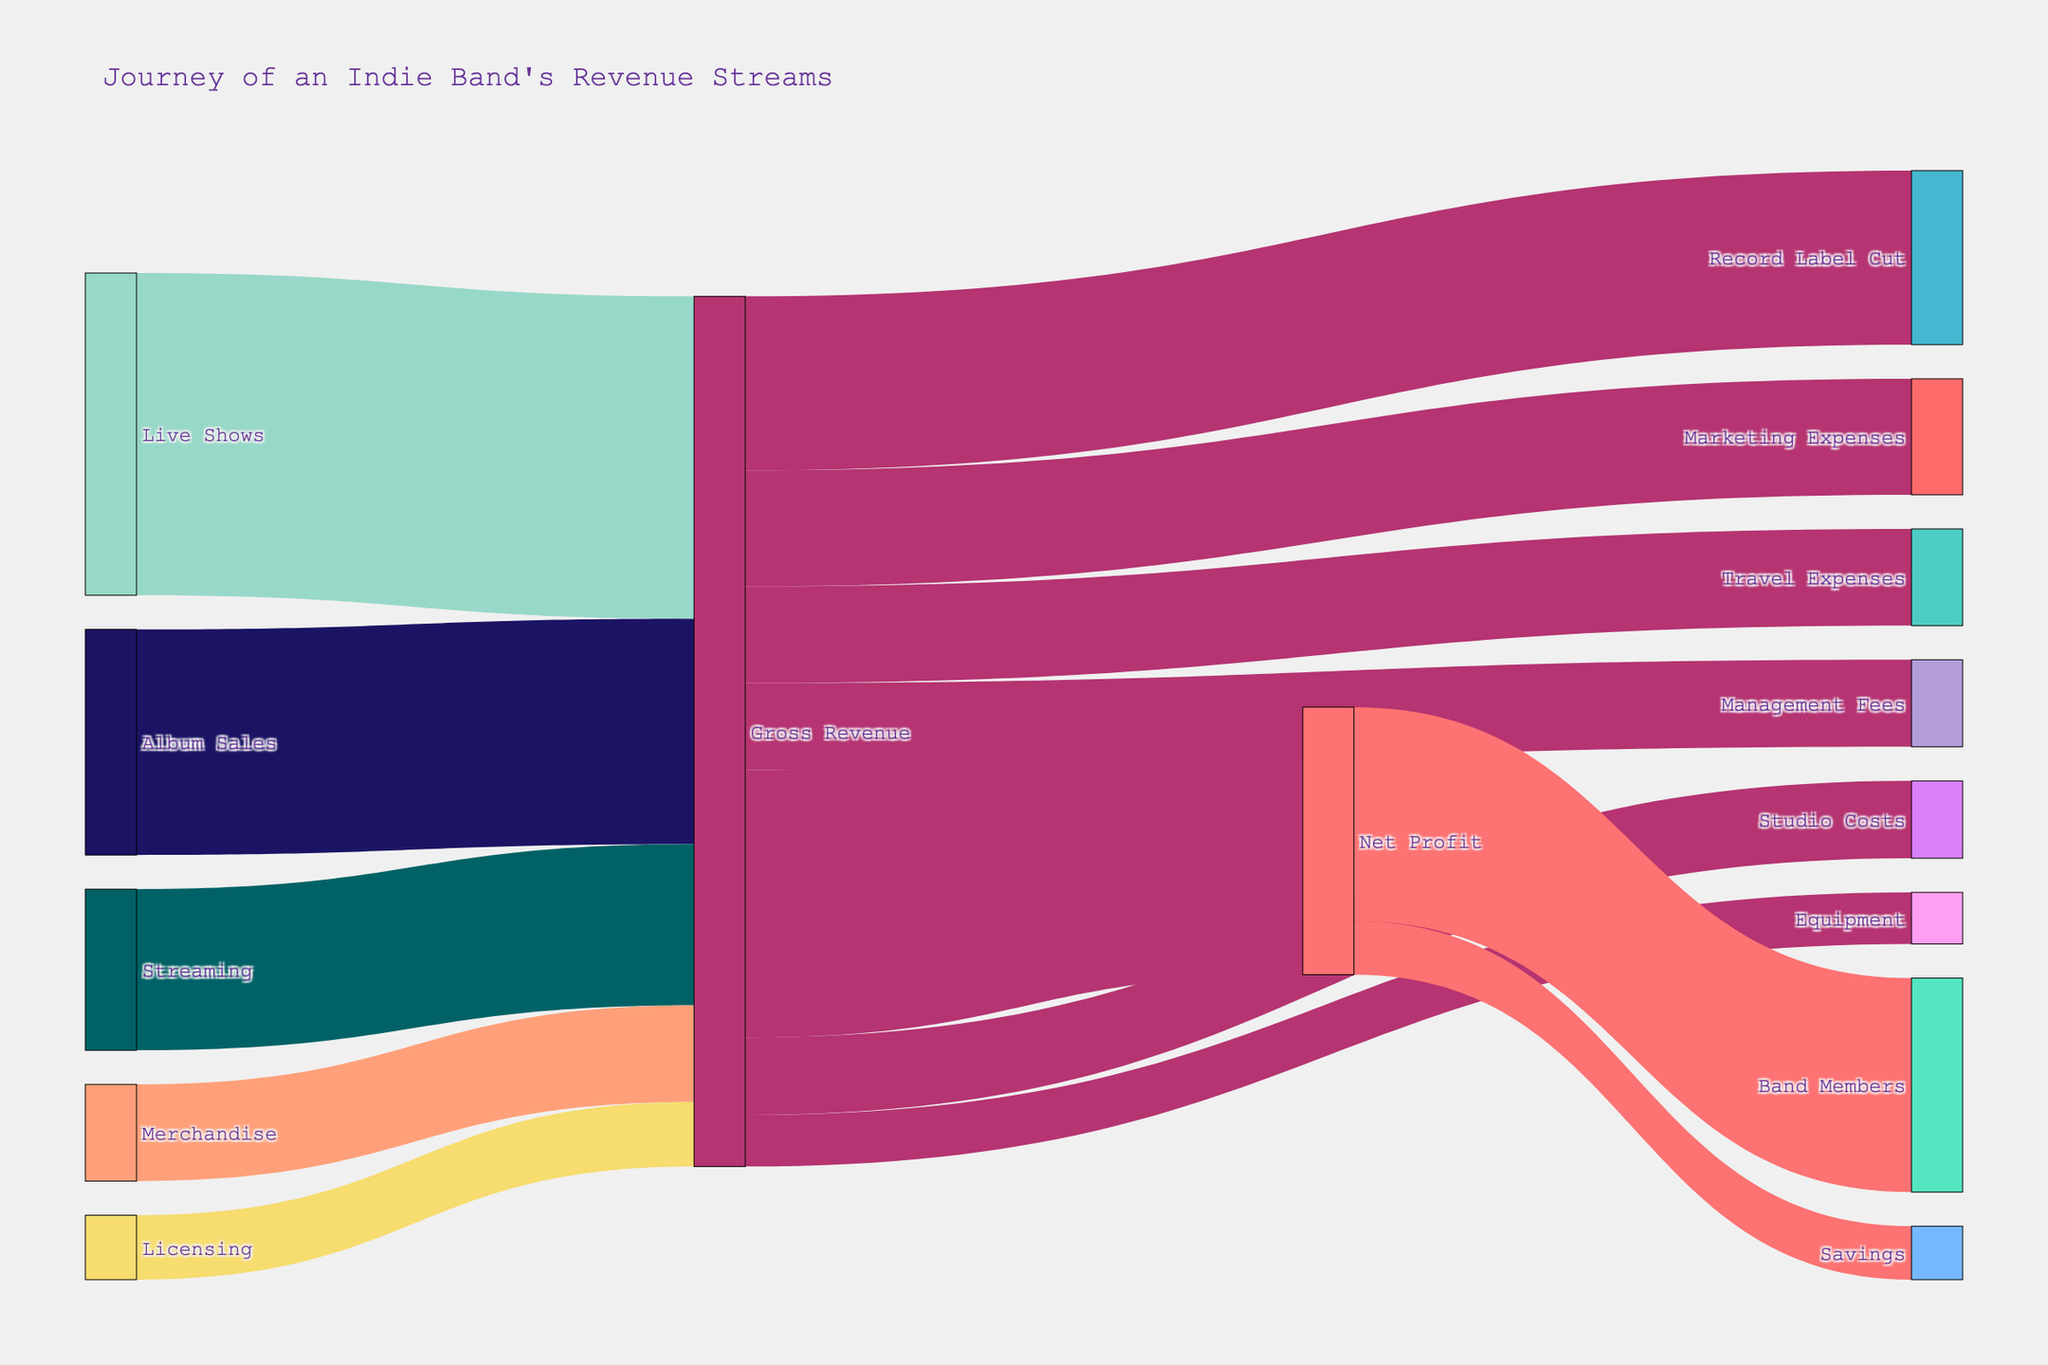what is the total value of gross revenue? To find the total value of gross revenue, sum up all the incoming values directed towards 'Gross Revenue'. This includes Album Sales (35000), Streaming (25000), Merchandise (15000), Live Shows (50000), and Licensing (10000). Summing these values gives us 35000 + 25000 + 15000 + 50000 + 10000 = 135000.
Answer: 135000 What is the largest single expense from the gross revenue? The expenses from Gross Revenue include Record Label Cut (27000), Management Fees (13500), Marketing Expenses (18000), Studio Costs (12000), Equipment (8000), and Travel Expenses (15000). The largest single expense here is the Record Label Cut at 27000.
Answer: 27000 What percentage of gross revenue is net profit? To determine the percentage, the formula is (Net Profit / Gross Revenue) * 100. The Net Profit is 41500, and Gross Revenue is 135000. Hence, (41500 / 135000) * 100 = 30.74%.
Answer: 30.74% How much revenue was directed towards Band Members from net profit? From the chart, we see that from 'Net Profit' (41500), 'Band Members' receive 33200.
Answer: 33200 What is the total value deducted from gross revenue? To find the total value deducted, sum up all the outgoing values from 'Gross Revenue': Record Label Cut (27000), Management Fees (13500), Marketing Expenses (18000), Studio Costs (12000), Equipment (8000), Travel Expenses (15000). Adding these values: 27000 + 13500 + 18000 + 12000 + 8000 + 15000 = 93500.
Answer: 93500 Which revenue source contributes the least to gross revenue? By comparing the values directed towards Gross Revenue, Licensing contributes the least with 10000.
Answer: Licensing What is the difference in value between Album Sales and Streaming? Album Sales contribute 35000, whereas Streaming contributes 25000. The difference is 35000 - 25000 = 10000.
Answer: 10000 How much is saved from the net profit? From the chart, we see that from 'Net Profit' (41500), 'Savings' receives 8300.
Answer: 8300 Which expense is contributed equally to Management Fees and has the same value? Both 'Management Fees' and 'Travel Expenses' from Gross Revenue are 13500.
Answer: Travel Expenses 